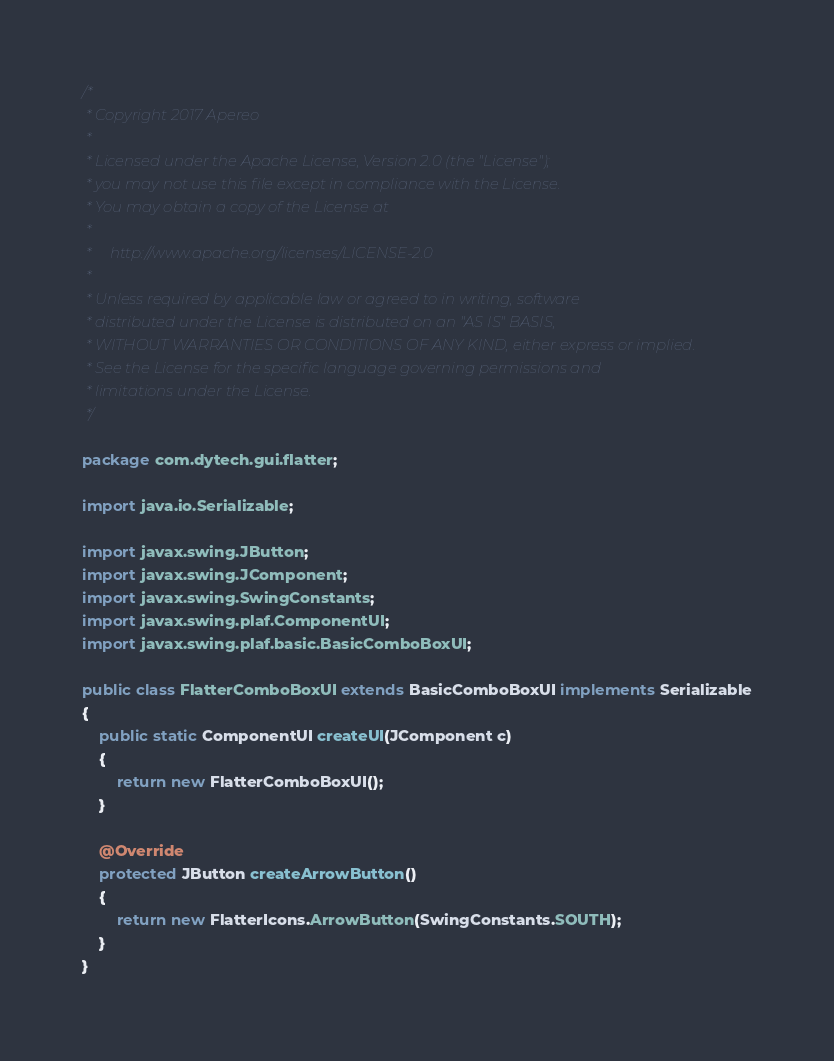Convert code to text. <code><loc_0><loc_0><loc_500><loc_500><_Java_>/*
 * Copyright 2017 Apereo
 *
 * Licensed under the Apache License, Version 2.0 (the "License");
 * you may not use this file except in compliance with the License.
 * You may obtain a copy of the License at
 *
 *     http://www.apache.org/licenses/LICENSE-2.0
 *
 * Unless required by applicable law or agreed to in writing, software
 * distributed under the License is distributed on an "AS IS" BASIS,
 * WITHOUT WARRANTIES OR CONDITIONS OF ANY KIND, either express or implied.
 * See the License for the specific language governing permissions and
 * limitations under the License.
 */

package com.dytech.gui.flatter;

import java.io.Serializable;

import javax.swing.JButton;
import javax.swing.JComponent;
import javax.swing.SwingConstants;
import javax.swing.plaf.ComponentUI;
import javax.swing.plaf.basic.BasicComboBoxUI;

public class FlatterComboBoxUI extends BasicComboBoxUI implements Serializable
{
	public static ComponentUI createUI(JComponent c)
	{
		return new FlatterComboBoxUI();
	}

	@Override
	protected JButton createArrowButton()
	{
		return new FlatterIcons.ArrowButton(SwingConstants.SOUTH);
	}
}
</code> 